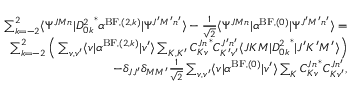Convert formula to latex. <formula><loc_0><loc_0><loc_500><loc_500>\begin{array} { r } { \sum _ { k = - 2 } ^ { 2 } \langle \Psi ^ { J M n } | { D _ { 0 k } ^ { 2 } } ^ { * } \alpha ^ { B F , ( 2 , k ) } | \Psi ^ { J ^ { \prime } M ^ { \prime } n ^ { \prime } } \rangle - \frac { 1 } { \sqrt { 2 } } \langle \Psi ^ { J M n } | \alpha ^ { B F , ( 0 ) } | \Psi ^ { J ^ { \prime } M ^ { \prime } n ^ { \prime } } \rangle = } \\ { \sum _ { k = - 2 } ^ { 2 } \left ( \sum _ { v , v ^ { \prime } } \langle v | \alpha ^ { B F , ( 2 , k ) } | v ^ { \prime } \rangle \sum _ { K , K ^ { \prime } } { C _ { K v } ^ { J n } } ^ { * } C _ { K ^ { \prime } v ^ { \prime } } ^ { J ^ { \prime } n ^ { \prime } } \langle J K M | { D _ { 0 k } ^ { 2 } } ^ { * } | J ^ { \prime } K ^ { \prime } M ^ { \prime } \rangle \right ) } \\ { - \delta _ { J J ^ { \prime } } \delta _ { M M ^ { \prime } } \frac { 1 } { \sqrt { 2 } } \sum _ { v , v ^ { \prime } } \langle v | \alpha ^ { B F , ( 0 ) } | v ^ { \prime } \rangle \sum _ { K } { C _ { K v } ^ { J n } } ^ { * } C _ { K v ^ { \prime } } ^ { J n ^ { \prime } } , } \end{array}</formula> 